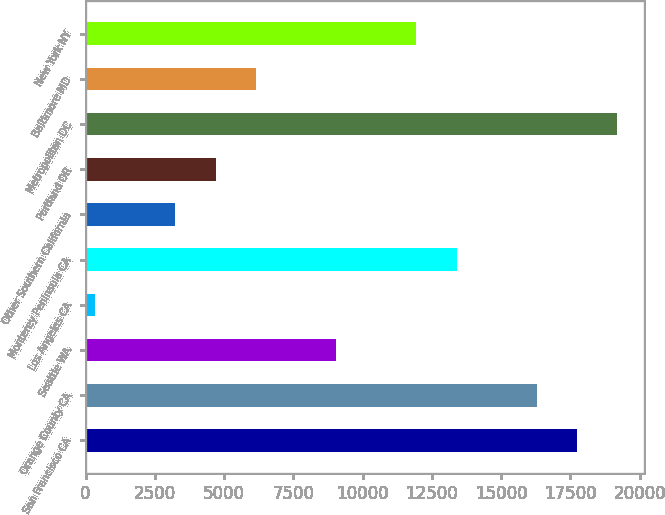Convert chart. <chart><loc_0><loc_0><loc_500><loc_500><bar_chart><fcel>San Francisco CA<fcel>Orange County CA<fcel>Seattle WA<fcel>Los Angeles CA<fcel>Monterey Peninsula CA<fcel>Other Southern California<fcel>Portland OR<fcel>Metropolitan DC<fcel>Baltimore MD<fcel>New York NY<nl><fcel>17739.2<fcel>16289.6<fcel>9041.6<fcel>344<fcel>13390.4<fcel>3243.2<fcel>4692.8<fcel>19188.8<fcel>6142.4<fcel>11940.8<nl></chart> 